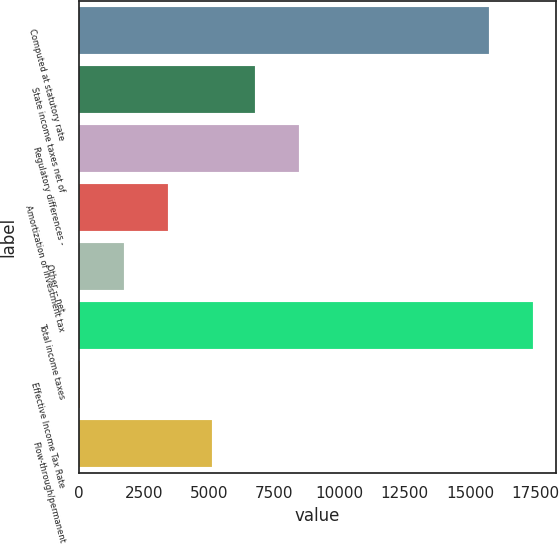Convert chart. <chart><loc_0><loc_0><loc_500><loc_500><bar_chart><fcel>Computed at statutory rate<fcel>State income taxes net of<fcel>Regulatory differences -<fcel>Amortization of investment tax<fcel>Other -- net<fcel>Total income taxes<fcel>Effective Income Tax Rate<fcel>Flow-through/permanent<nl><fcel>15729<fcel>6769.7<fcel>8452.75<fcel>3403.6<fcel>1720.55<fcel>17412<fcel>37.5<fcel>5086.65<nl></chart> 